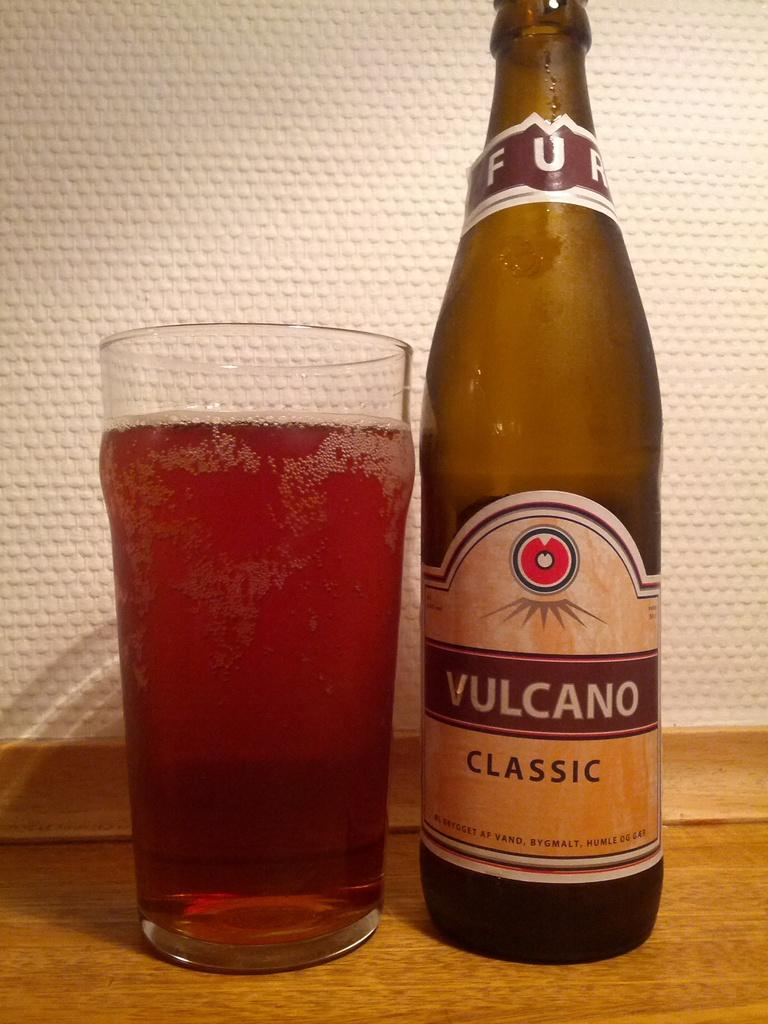<image>
Write a terse but informative summary of the picture. a glass and bottle of Vulcano Classic on a wooden table 